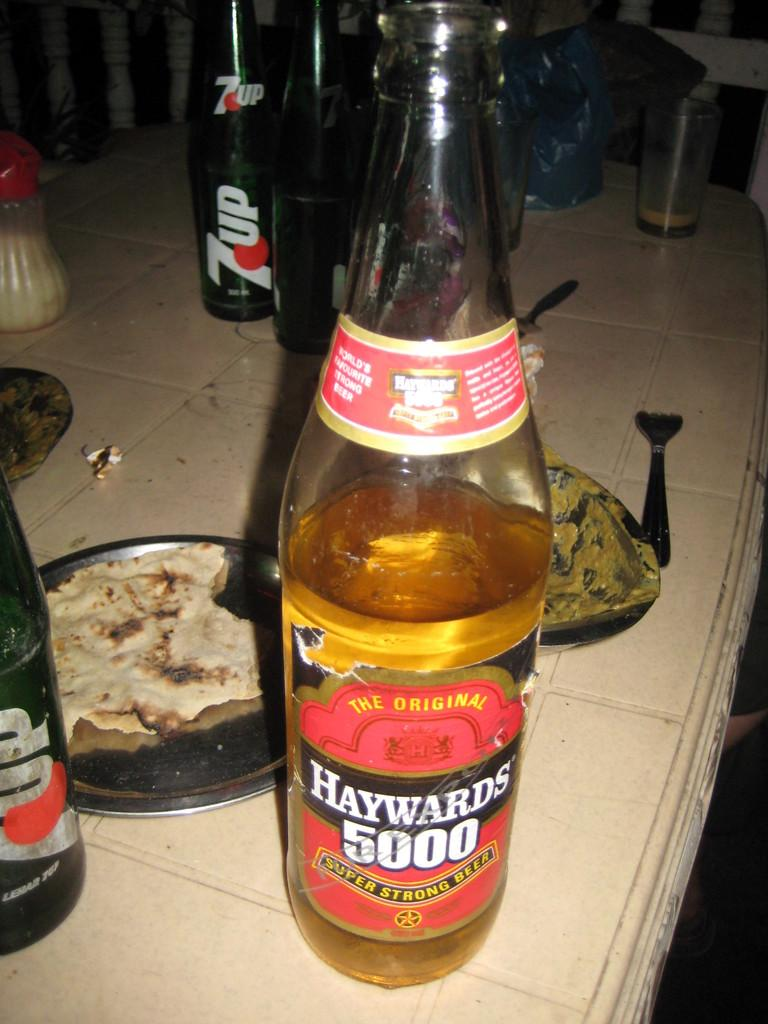What type of furniture is present in the image? There is a table in the image. What is on the table in the image? There is food on the table. Are there any beverages present in the image? Yes, there are alcohol bottles on or near the table. What type of seasoning is visible in the image? There is a salt bottle in the image. What type of holiday decoration can be seen on the table in the image? There is no holiday decoration present in the image. What type of coil is used to cook the food in the image? There is no coil visible in the image; it is not a cooking scene. 